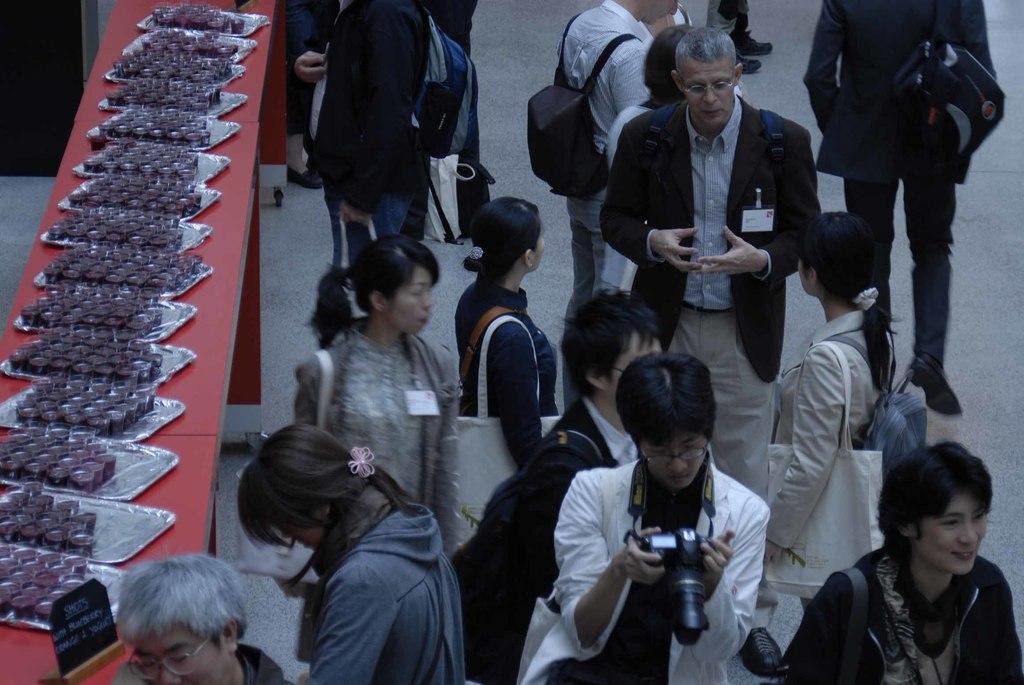How would you summarize this image in a sentence or two? In this picture we can see so many people are standing in one place, side we can see a slope thing on which some plates are arranged. 